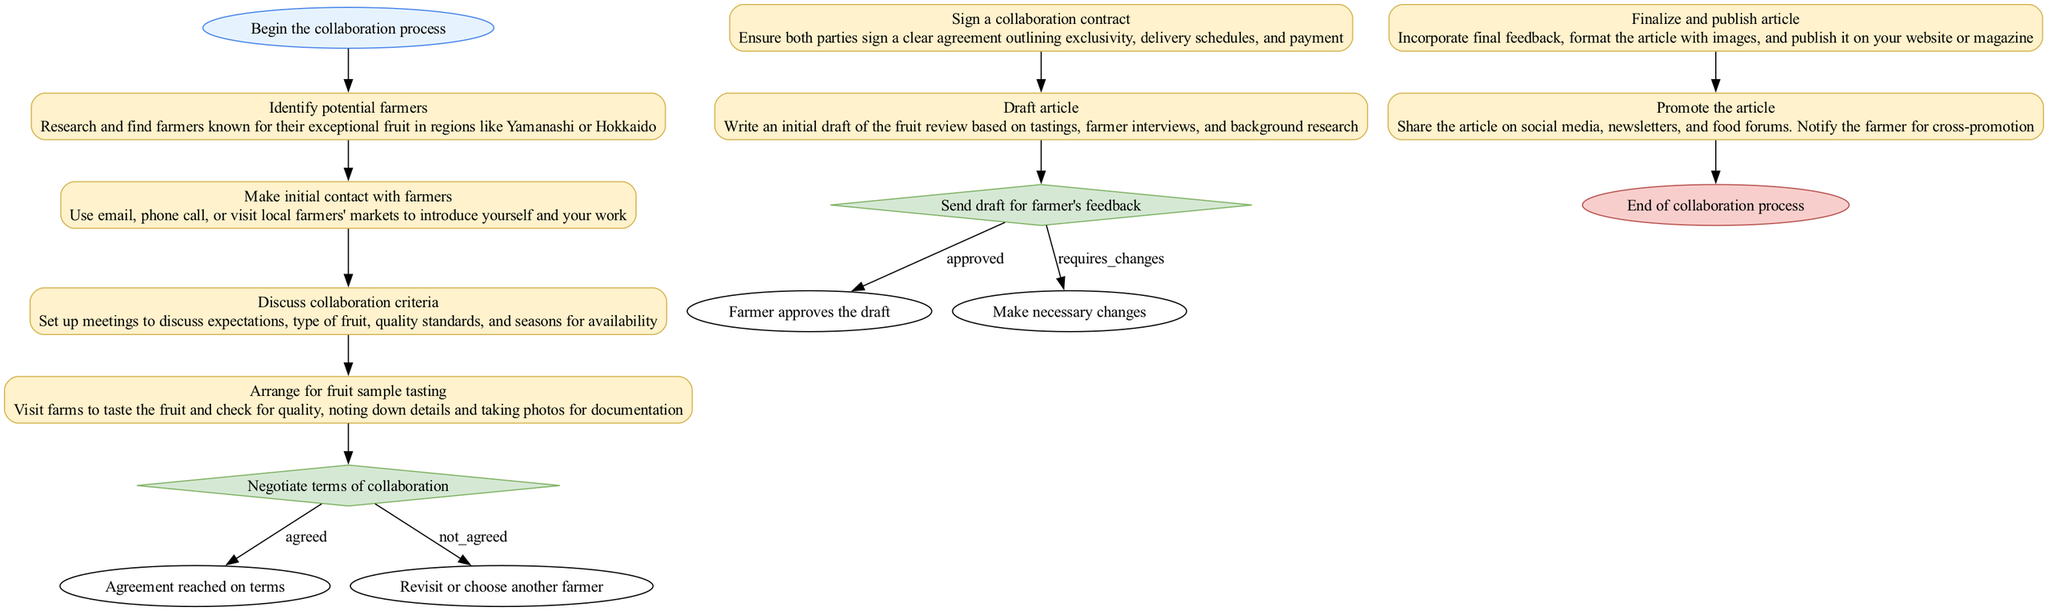What's the first step in the collaboration process? The diagram indicates that the first step is labeled "Begin the collaboration process".
Answer: Begin the collaboration process How many decisions are present in the flowchart? The flowchart contains two decision nodes: one for negotiating terms and another for reviewing feedback on the article draft.
Answer: 2 What is the outcome if terms of collaboration are not agreed upon? If terms are not agreed upon, the process indicates that you should "Revisit or choose another farmer".
Answer: Revisit or choose another farmer Which step comes after discussing collaboration criteria? After discussing collaboration criteria, the next action is to "Arrange for fruit sample tasting".
Answer: Arrange for fruit sample tasting What is the last action that takes place before the end of the process? The last action that occurs before the process ends is "Promote the article", marking an important step in the dissemination of the work.
Answer: Promote the article What is required from the farmer after the article draft is sent? The farmer needs to provide feedback after the article draft is sent for review.
Answer: Feedback How does one finalize the article in the process? To finalize the article, you must incorporate final feedback, format it with images, and then proceed to publish it.
Answer: Incorporate final feedback, format with images, and publish What step follows the initial contact with farmers? The step following the initial contact with farmers is to "Discuss collaboration criteria".
Answer: Discuss collaboration criteria What is the action taken if the farmer requires changes on the draft? If the farmer requires changes, the flowchart indicates to "Make necessary changes" to the draft.
Answer: Make necessary changes 